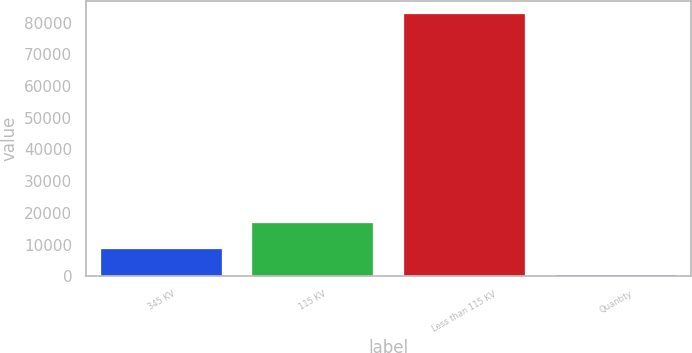Convert chart to OTSL. <chart><loc_0><loc_0><loc_500><loc_500><bar_chart><fcel>345 KV<fcel>115 KV<fcel>Less than 115 KV<fcel>Quantity<nl><fcel>8615.7<fcel>16856.4<fcel>82782<fcel>375<nl></chart> 